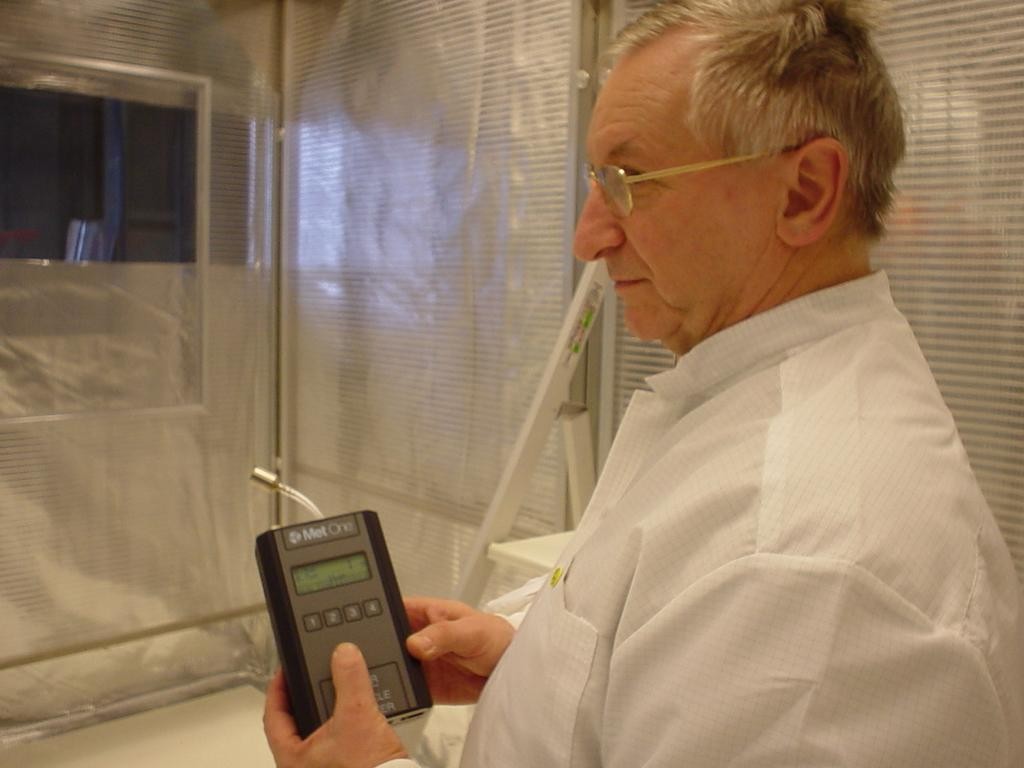What is the main subject of the image? The main subject of the image is a man. What is the man doing in the image? The man is standing in the image. What is the man holding in his hands? The man is holding an object in his hands. Can you describe the man's appearance? The man is wearing spectacles and a shirt. What can be seen in the background of the image? There are objects visible in the background of the image. What type of recess can be seen in the image? There is no recess present in the image; it features a man standing and holding an object. What type of party is the man attending in the image? There is no indication of a party in the image; it simply shows a man standing and holding an object. 